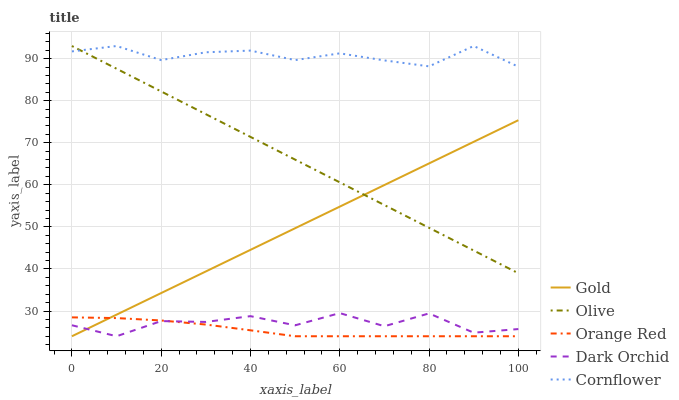Does Orange Red have the minimum area under the curve?
Answer yes or no. Yes. Does Cornflower have the maximum area under the curve?
Answer yes or no. Yes. Does Dark Orchid have the minimum area under the curve?
Answer yes or no. No. Does Dark Orchid have the maximum area under the curve?
Answer yes or no. No. Is Olive the smoothest?
Answer yes or no. Yes. Is Dark Orchid the roughest?
Answer yes or no. Yes. Is Cornflower the smoothest?
Answer yes or no. No. Is Cornflower the roughest?
Answer yes or no. No. Does Dark Orchid have the lowest value?
Answer yes or no. Yes. Does Cornflower have the lowest value?
Answer yes or no. No. Does Cornflower have the highest value?
Answer yes or no. Yes. Does Dark Orchid have the highest value?
Answer yes or no. No. Is Dark Orchid less than Olive?
Answer yes or no. Yes. Is Cornflower greater than Gold?
Answer yes or no. Yes. Does Dark Orchid intersect Gold?
Answer yes or no. Yes. Is Dark Orchid less than Gold?
Answer yes or no. No. Is Dark Orchid greater than Gold?
Answer yes or no. No. Does Dark Orchid intersect Olive?
Answer yes or no. No. 